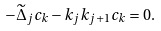<formula> <loc_0><loc_0><loc_500><loc_500>- \widetilde { \Delta } _ { j } c _ { k } - k _ { j } k _ { j + 1 } c _ { k } = 0 .</formula> 